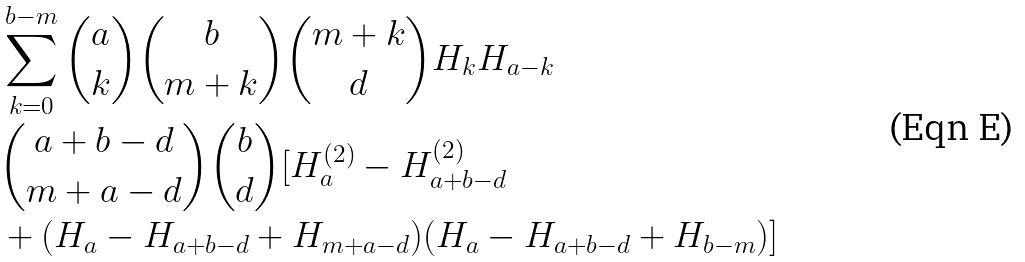<formula> <loc_0><loc_0><loc_500><loc_500>& \sum _ { k = 0 } ^ { b - m } \binom { a } { k } \binom { b } { m + k } \binom { m + k } { d } H _ { k } H _ { a - k } \\ & \binom { a + b - d } { m + a - d } \binom { b } { d } [ H _ { a } ^ { ( 2 ) } - H _ { a + b - d } ^ { ( 2 ) } \\ & + ( H _ { a } - H _ { a + b - d } + H _ { m + a - d } ) ( H _ { a } - H _ { a + b - d } + H _ { b - m } ) ]</formula> 